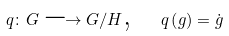<formula> <loc_0><loc_0><loc_500><loc_500>q \colon G \longrightarrow G / H \text {,} \quad q \left ( g \right ) = \dot { g }</formula> 